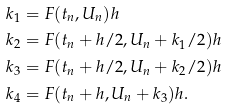Convert formula to latex. <formula><loc_0><loc_0><loc_500><loc_500>k _ { 1 } & = F ( t _ { n } , U _ { n } ) h \\ k _ { 2 } & = F ( t _ { n } + h / 2 , U _ { n } + k _ { 1 } / 2 ) h \\ k _ { 3 } & = F ( t _ { n } + h / 2 , U _ { n } + k _ { 2 } / 2 ) h \\ k _ { 4 } & = F ( t _ { n } + h , U _ { n } + k _ { 3 } ) h .</formula> 